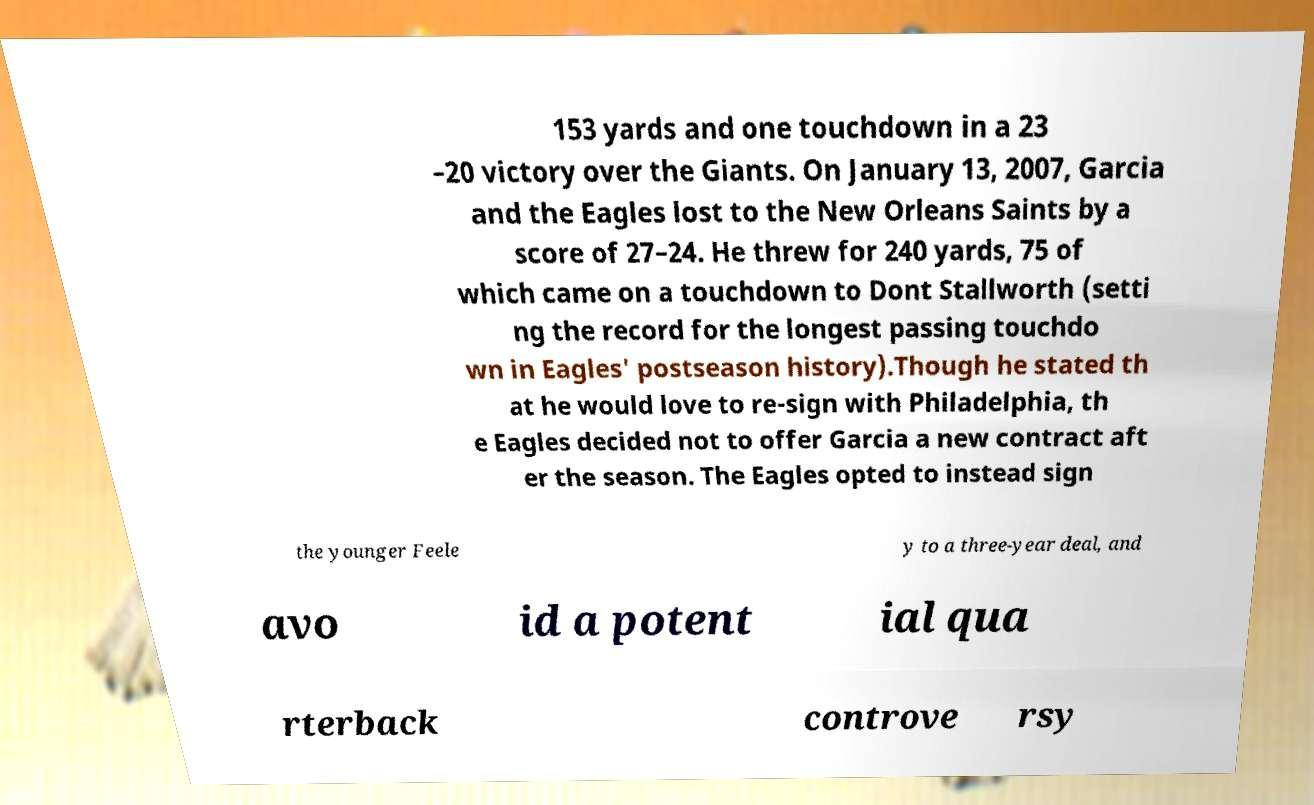Please read and relay the text visible in this image. What does it say? 153 yards and one touchdown in a 23 –20 victory over the Giants. On January 13, 2007, Garcia and the Eagles lost to the New Orleans Saints by a score of 27–24. He threw for 240 yards, 75 of which came on a touchdown to Dont Stallworth (setti ng the record for the longest passing touchdo wn in Eagles' postseason history).Though he stated th at he would love to re-sign with Philadelphia, th e Eagles decided not to offer Garcia a new contract aft er the season. The Eagles opted to instead sign the younger Feele y to a three-year deal, and avo id a potent ial qua rterback controve rsy 